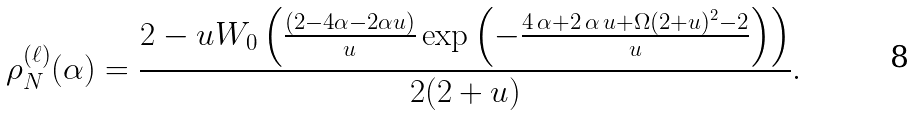<formula> <loc_0><loc_0><loc_500><loc_500>\rho _ { N } ^ { ( \ell ) } ( \alpha ) = \frac { 2 - u W _ { 0 } \left ( \frac { ( 2 - 4 \alpha - 2 \alpha u ) } { u } \exp \left ( { - { \frac { 4 \, \alpha + 2 \, \alpha \, u + \Omega ( 2 + u ) ^ { 2 } - 2 } { u } } } \right ) \right ) } { 2 ( 2 + u ) } .</formula> 